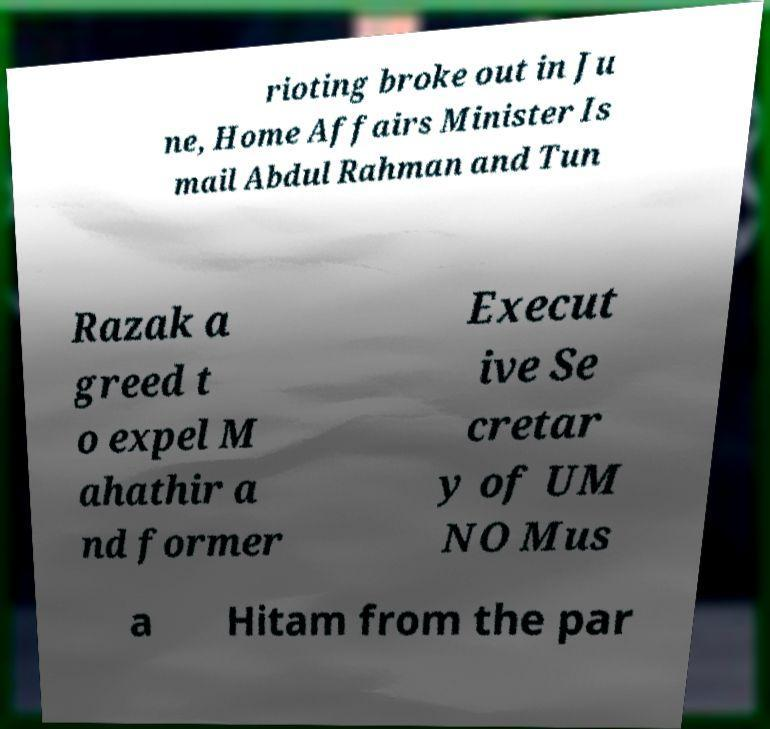Could you assist in decoding the text presented in this image and type it out clearly? rioting broke out in Ju ne, Home Affairs Minister Is mail Abdul Rahman and Tun Razak a greed t o expel M ahathir a nd former Execut ive Se cretar y of UM NO Mus a Hitam from the par 